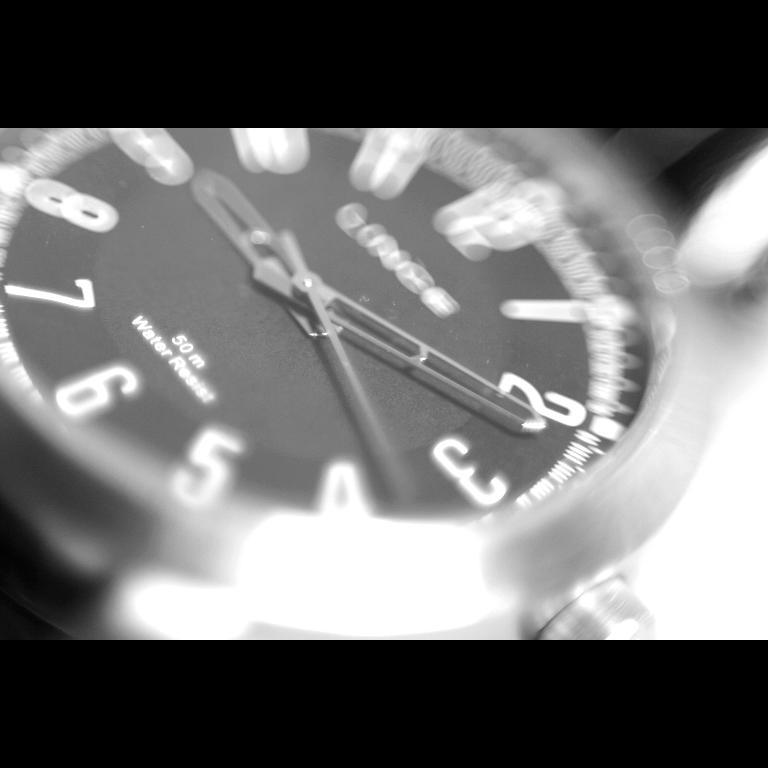Provide a one-sentence caption for the provided image. A watch with a black face showing the time of 9:11. 